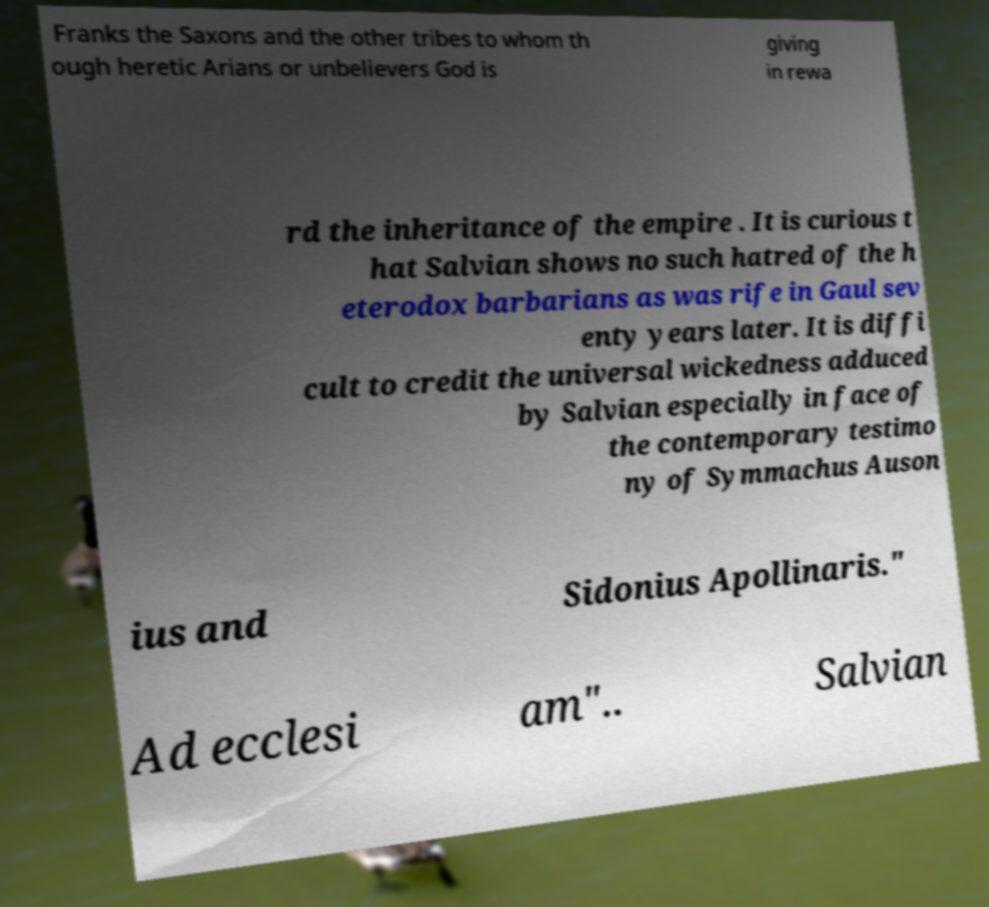Please read and relay the text visible in this image. What does it say? Franks the Saxons and the other tribes to whom th ough heretic Arians or unbelievers God is giving in rewa rd the inheritance of the empire . It is curious t hat Salvian shows no such hatred of the h eterodox barbarians as was rife in Gaul sev enty years later. It is diffi cult to credit the universal wickedness adduced by Salvian especially in face of the contemporary testimo ny of Symmachus Auson ius and Sidonius Apollinaris." Ad ecclesi am".. Salvian 